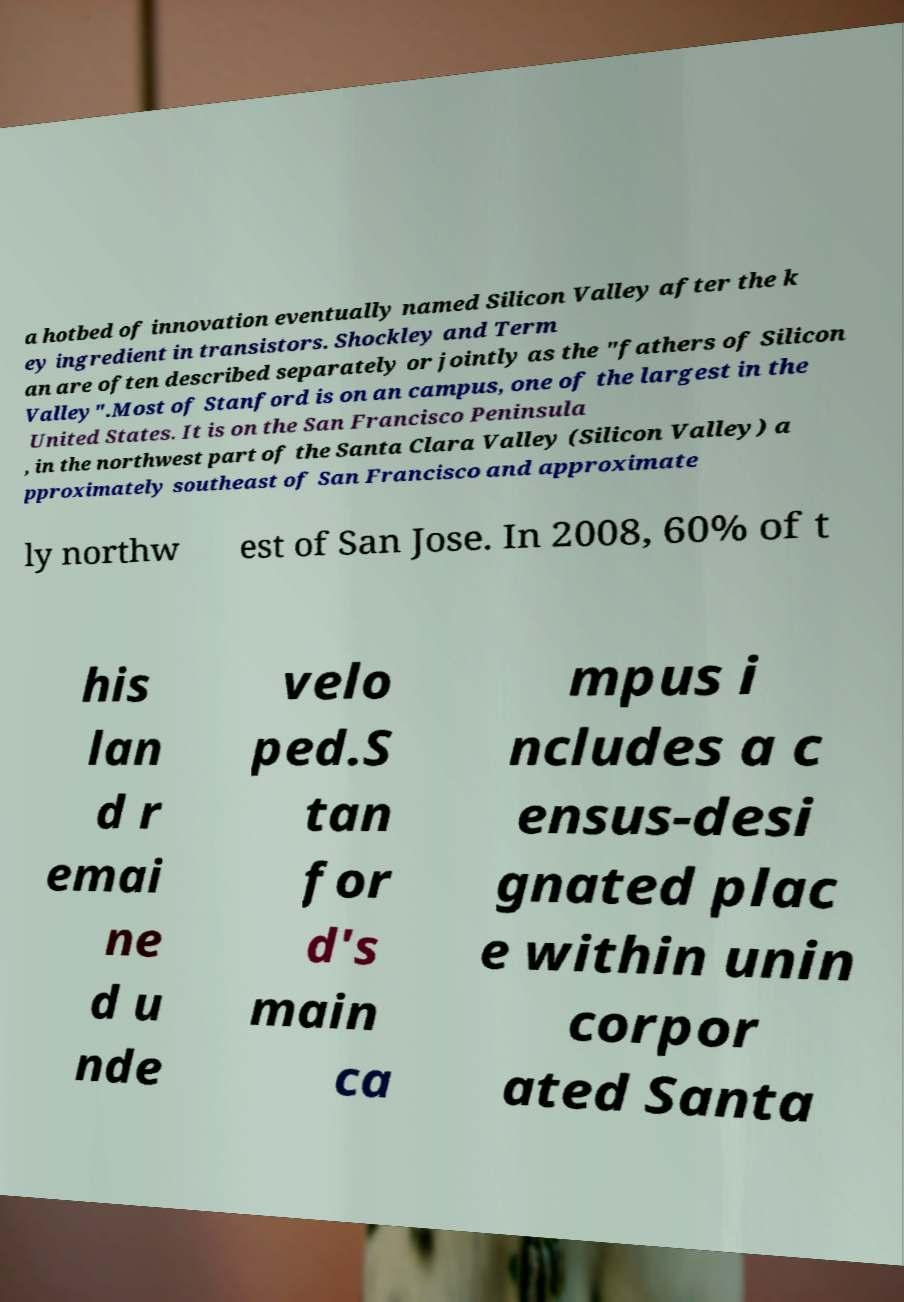Please read and relay the text visible in this image. What does it say? a hotbed of innovation eventually named Silicon Valley after the k ey ingredient in transistors. Shockley and Term an are often described separately or jointly as the "fathers of Silicon Valley".Most of Stanford is on an campus, one of the largest in the United States. It is on the San Francisco Peninsula , in the northwest part of the Santa Clara Valley (Silicon Valley) a pproximately southeast of San Francisco and approximate ly northw est of San Jose. In 2008, 60% of t his lan d r emai ne d u nde velo ped.S tan for d's main ca mpus i ncludes a c ensus-desi gnated plac e within unin corpor ated Santa 